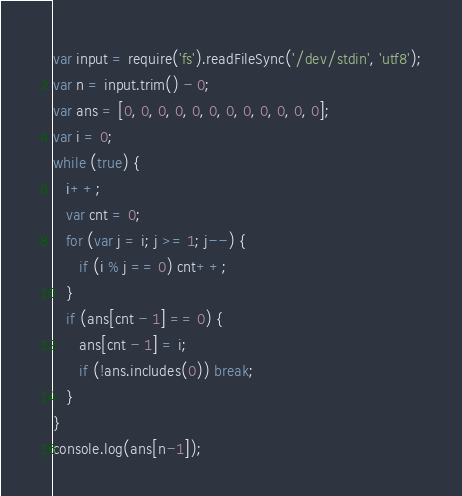Convert code to text. <code><loc_0><loc_0><loc_500><loc_500><_JavaScript_>var input = require('fs').readFileSync('/dev/stdin', 'utf8');
var n = input.trim() - 0;
var ans = [0, 0, 0, 0, 0, 0, 0, 0, 0, 0, 0, 0];
var i = 0;
while (true) {
   i++;
   var cnt = 0;
   for (var j = i; j >= 1; j--) {
      if (i % j == 0) cnt++;
   }
   if (ans[cnt - 1] == 0) {
      ans[cnt - 1] = i;
      if (!ans.includes(0)) break;
   }
}
console.log(ans[n-1]);
</code> 